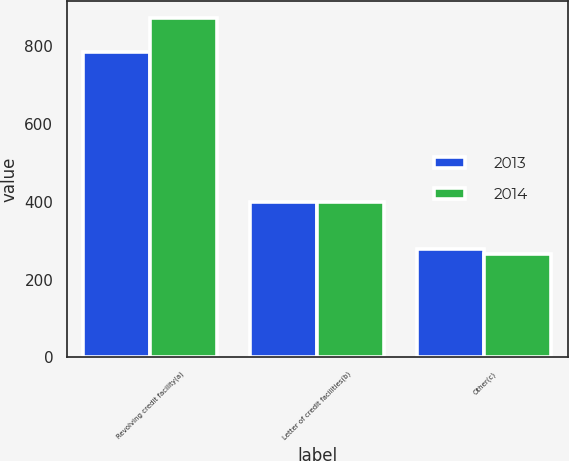Convert chart. <chart><loc_0><loc_0><loc_500><loc_500><stacked_bar_chart><ecel><fcel>Revolving credit facility(a)<fcel>Letter of credit facilities(b)<fcel>Other(c)<nl><fcel>2013<fcel>785<fcel>400<fcel>278<nl><fcel>2014<fcel>872<fcel>400<fcel>267<nl></chart> 